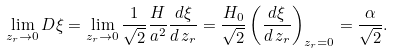<formula> <loc_0><loc_0><loc_500><loc_500>\lim _ { z _ { r } \rightarrow 0 } D \xi = \lim _ { z _ { r } \rightarrow 0 } \frac { 1 } { \sqrt { 2 } } \frac { H } { a ^ { 2 } } \frac { d \xi } { d \, z _ { r } } = \frac { H _ { 0 } } { \sqrt { 2 } } \left ( \frac { d \xi } { d \, z _ { r } } \right ) _ { z _ { r } = 0 } = \frac { \alpha } { \sqrt { 2 } } .</formula> 